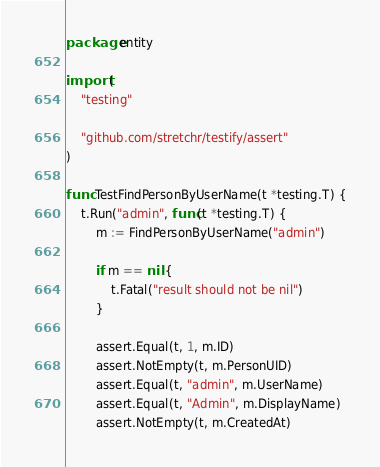Convert code to text. <code><loc_0><loc_0><loc_500><loc_500><_Go_>package entity

import (
	"testing"

	"github.com/stretchr/testify/assert"
)

func TestFindPersonByUserName(t *testing.T) {
	t.Run("admin", func(t *testing.T) {
		m := FindPersonByUserName("admin")

		if m == nil {
			t.Fatal("result should not be nil")
		}

		assert.Equal(t, 1, m.ID)
		assert.NotEmpty(t, m.PersonUID)
		assert.Equal(t, "admin", m.UserName)
		assert.Equal(t, "Admin", m.DisplayName)
		assert.NotEmpty(t, m.CreatedAt)</code> 